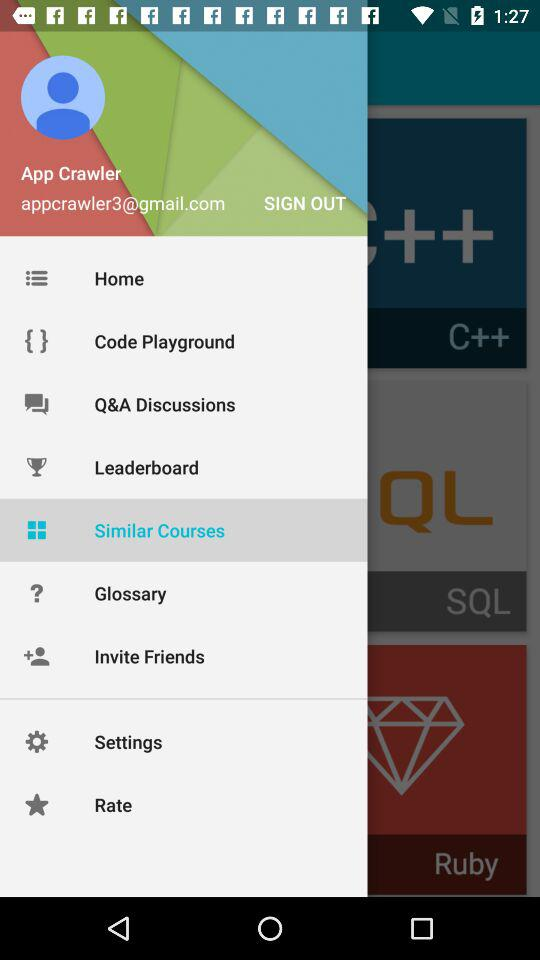What is the email address of the user? The email address of the user is appcrawler3@gmail.com. 